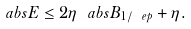<formula> <loc_0><loc_0><loc_500><loc_500>\ a b s { E } \leq 2 \eta \ a b s { B _ { 1 / \ e p } } + \eta .</formula> 